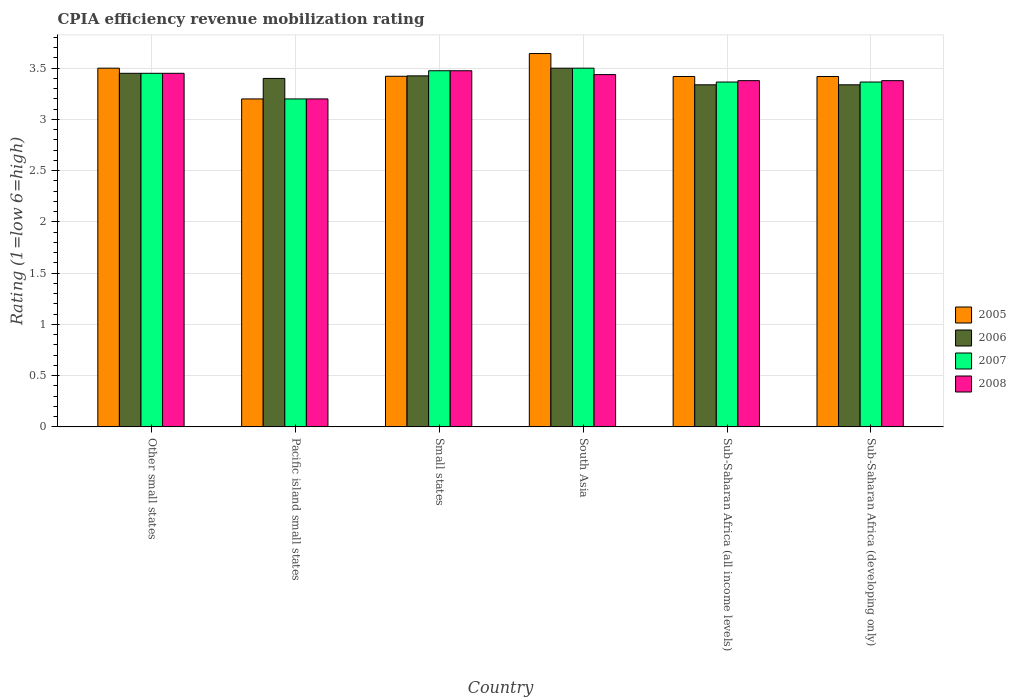Are the number of bars per tick equal to the number of legend labels?
Your answer should be very brief. Yes. Are the number of bars on each tick of the X-axis equal?
Keep it short and to the point. Yes. How many bars are there on the 4th tick from the right?
Offer a very short reply. 4. What is the label of the 3rd group of bars from the left?
Offer a very short reply. Small states. In how many cases, is the number of bars for a given country not equal to the number of legend labels?
Make the answer very short. 0. What is the CPIA rating in 2008 in Small states?
Keep it short and to the point. 3.48. In which country was the CPIA rating in 2007 maximum?
Your answer should be very brief. South Asia. In which country was the CPIA rating in 2007 minimum?
Make the answer very short. Pacific island small states. What is the total CPIA rating in 2007 in the graph?
Your response must be concise. 20.35. What is the difference between the CPIA rating in 2005 in South Asia and the CPIA rating in 2007 in Sub-Saharan Africa (all income levels)?
Provide a succinct answer. 0.28. What is the average CPIA rating in 2006 per country?
Keep it short and to the point. 3.41. What is the difference between the CPIA rating of/in 2007 and CPIA rating of/in 2006 in Sub-Saharan Africa (developing only)?
Offer a terse response. 0.03. What is the ratio of the CPIA rating in 2008 in Pacific island small states to that in Sub-Saharan Africa (developing only)?
Offer a very short reply. 0.95. Is the difference between the CPIA rating in 2007 in Pacific island small states and Sub-Saharan Africa (all income levels) greater than the difference between the CPIA rating in 2006 in Pacific island small states and Sub-Saharan Africa (all income levels)?
Your answer should be very brief. No. What is the difference between the highest and the second highest CPIA rating in 2008?
Provide a short and direct response. 0.01. What is the difference between the highest and the lowest CPIA rating in 2007?
Offer a very short reply. 0.3. Is the sum of the CPIA rating in 2008 in Other small states and Pacific island small states greater than the maximum CPIA rating in 2006 across all countries?
Your answer should be compact. Yes. Is it the case that in every country, the sum of the CPIA rating in 2006 and CPIA rating in 2008 is greater than the sum of CPIA rating in 2005 and CPIA rating in 2007?
Your answer should be compact. No. What does the 4th bar from the right in Pacific island small states represents?
Provide a succinct answer. 2005. Is it the case that in every country, the sum of the CPIA rating in 2007 and CPIA rating in 2006 is greater than the CPIA rating in 2005?
Your answer should be very brief. Yes. How many bars are there?
Your answer should be compact. 24. Are all the bars in the graph horizontal?
Make the answer very short. No. How many countries are there in the graph?
Give a very brief answer. 6. What is the difference between two consecutive major ticks on the Y-axis?
Offer a very short reply. 0.5. Are the values on the major ticks of Y-axis written in scientific E-notation?
Your response must be concise. No. Does the graph contain any zero values?
Ensure brevity in your answer.  No. Does the graph contain grids?
Give a very brief answer. Yes. Where does the legend appear in the graph?
Offer a terse response. Center right. What is the title of the graph?
Your answer should be compact. CPIA efficiency revenue mobilization rating. What is the Rating (1=low 6=high) of 2005 in Other small states?
Keep it short and to the point. 3.5. What is the Rating (1=low 6=high) of 2006 in Other small states?
Ensure brevity in your answer.  3.45. What is the Rating (1=low 6=high) in 2007 in Other small states?
Provide a succinct answer. 3.45. What is the Rating (1=low 6=high) of 2008 in Other small states?
Your answer should be compact. 3.45. What is the Rating (1=low 6=high) of 2005 in Small states?
Provide a short and direct response. 3.42. What is the Rating (1=low 6=high) of 2006 in Small states?
Offer a terse response. 3.42. What is the Rating (1=low 6=high) of 2007 in Small states?
Keep it short and to the point. 3.48. What is the Rating (1=low 6=high) of 2008 in Small states?
Keep it short and to the point. 3.48. What is the Rating (1=low 6=high) in 2005 in South Asia?
Give a very brief answer. 3.64. What is the Rating (1=low 6=high) in 2006 in South Asia?
Ensure brevity in your answer.  3.5. What is the Rating (1=low 6=high) of 2007 in South Asia?
Offer a terse response. 3.5. What is the Rating (1=low 6=high) of 2008 in South Asia?
Ensure brevity in your answer.  3.44. What is the Rating (1=low 6=high) of 2005 in Sub-Saharan Africa (all income levels)?
Provide a succinct answer. 3.42. What is the Rating (1=low 6=high) in 2006 in Sub-Saharan Africa (all income levels)?
Ensure brevity in your answer.  3.34. What is the Rating (1=low 6=high) of 2007 in Sub-Saharan Africa (all income levels)?
Keep it short and to the point. 3.36. What is the Rating (1=low 6=high) in 2008 in Sub-Saharan Africa (all income levels)?
Ensure brevity in your answer.  3.38. What is the Rating (1=low 6=high) in 2005 in Sub-Saharan Africa (developing only)?
Provide a succinct answer. 3.42. What is the Rating (1=low 6=high) in 2006 in Sub-Saharan Africa (developing only)?
Make the answer very short. 3.34. What is the Rating (1=low 6=high) of 2007 in Sub-Saharan Africa (developing only)?
Give a very brief answer. 3.36. What is the Rating (1=low 6=high) in 2008 in Sub-Saharan Africa (developing only)?
Provide a short and direct response. 3.38. Across all countries, what is the maximum Rating (1=low 6=high) in 2005?
Keep it short and to the point. 3.64. Across all countries, what is the maximum Rating (1=low 6=high) in 2008?
Keep it short and to the point. 3.48. Across all countries, what is the minimum Rating (1=low 6=high) of 2006?
Offer a terse response. 3.34. Across all countries, what is the minimum Rating (1=low 6=high) of 2007?
Ensure brevity in your answer.  3.2. Across all countries, what is the minimum Rating (1=low 6=high) of 2008?
Your answer should be compact. 3.2. What is the total Rating (1=low 6=high) in 2005 in the graph?
Ensure brevity in your answer.  20.6. What is the total Rating (1=low 6=high) of 2006 in the graph?
Your response must be concise. 20.45. What is the total Rating (1=low 6=high) of 2007 in the graph?
Keep it short and to the point. 20.35. What is the total Rating (1=low 6=high) of 2008 in the graph?
Your answer should be compact. 20.32. What is the difference between the Rating (1=low 6=high) of 2006 in Other small states and that in Pacific island small states?
Offer a terse response. 0.05. What is the difference between the Rating (1=low 6=high) of 2005 in Other small states and that in Small states?
Give a very brief answer. 0.08. What is the difference between the Rating (1=low 6=high) of 2006 in Other small states and that in Small states?
Keep it short and to the point. 0.03. What is the difference between the Rating (1=low 6=high) in 2007 in Other small states and that in Small states?
Your response must be concise. -0.03. What is the difference between the Rating (1=low 6=high) in 2008 in Other small states and that in Small states?
Provide a short and direct response. -0.03. What is the difference between the Rating (1=low 6=high) in 2005 in Other small states and that in South Asia?
Ensure brevity in your answer.  -0.14. What is the difference between the Rating (1=low 6=high) in 2007 in Other small states and that in South Asia?
Provide a short and direct response. -0.05. What is the difference between the Rating (1=low 6=high) in 2008 in Other small states and that in South Asia?
Make the answer very short. 0.01. What is the difference between the Rating (1=low 6=high) of 2005 in Other small states and that in Sub-Saharan Africa (all income levels)?
Your response must be concise. 0.08. What is the difference between the Rating (1=low 6=high) of 2006 in Other small states and that in Sub-Saharan Africa (all income levels)?
Ensure brevity in your answer.  0.11. What is the difference between the Rating (1=low 6=high) in 2007 in Other small states and that in Sub-Saharan Africa (all income levels)?
Your answer should be compact. 0.09. What is the difference between the Rating (1=low 6=high) of 2008 in Other small states and that in Sub-Saharan Africa (all income levels)?
Offer a terse response. 0.07. What is the difference between the Rating (1=low 6=high) in 2005 in Other small states and that in Sub-Saharan Africa (developing only)?
Your answer should be very brief. 0.08. What is the difference between the Rating (1=low 6=high) of 2006 in Other small states and that in Sub-Saharan Africa (developing only)?
Your response must be concise. 0.11. What is the difference between the Rating (1=low 6=high) of 2007 in Other small states and that in Sub-Saharan Africa (developing only)?
Make the answer very short. 0.09. What is the difference between the Rating (1=low 6=high) in 2008 in Other small states and that in Sub-Saharan Africa (developing only)?
Ensure brevity in your answer.  0.07. What is the difference between the Rating (1=low 6=high) of 2005 in Pacific island small states and that in Small states?
Your answer should be compact. -0.22. What is the difference between the Rating (1=low 6=high) of 2006 in Pacific island small states and that in Small states?
Your response must be concise. -0.03. What is the difference between the Rating (1=low 6=high) of 2007 in Pacific island small states and that in Small states?
Your answer should be compact. -0.28. What is the difference between the Rating (1=low 6=high) of 2008 in Pacific island small states and that in Small states?
Make the answer very short. -0.28. What is the difference between the Rating (1=low 6=high) in 2005 in Pacific island small states and that in South Asia?
Offer a very short reply. -0.44. What is the difference between the Rating (1=low 6=high) of 2008 in Pacific island small states and that in South Asia?
Your answer should be very brief. -0.24. What is the difference between the Rating (1=low 6=high) in 2005 in Pacific island small states and that in Sub-Saharan Africa (all income levels)?
Give a very brief answer. -0.22. What is the difference between the Rating (1=low 6=high) in 2006 in Pacific island small states and that in Sub-Saharan Africa (all income levels)?
Make the answer very short. 0.06. What is the difference between the Rating (1=low 6=high) in 2007 in Pacific island small states and that in Sub-Saharan Africa (all income levels)?
Provide a succinct answer. -0.16. What is the difference between the Rating (1=low 6=high) of 2008 in Pacific island small states and that in Sub-Saharan Africa (all income levels)?
Your answer should be compact. -0.18. What is the difference between the Rating (1=low 6=high) of 2005 in Pacific island small states and that in Sub-Saharan Africa (developing only)?
Provide a succinct answer. -0.22. What is the difference between the Rating (1=low 6=high) of 2006 in Pacific island small states and that in Sub-Saharan Africa (developing only)?
Ensure brevity in your answer.  0.06. What is the difference between the Rating (1=low 6=high) in 2007 in Pacific island small states and that in Sub-Saharan Africa (developing only)?
Provide a succinct answer. -0.16. What is the difference between the Rating (1=low 6=high) in 2008 in Pacific island small states and that in Sub-Saharan Africa (developing only)?
Keep it short and to the point. -0.18. What is the difference between the Rating (1=low 6=high) in 2005 in Small states and that in South Asia?
Keep it short and to the point. -0.22. What is the difference between the Rating (1=low 6=high) in 2006 in Small states and that in South Asia?
Your response must be concise. -0.07. What is the difference between the Rating (1=low 6=high) in 2007 in Small states and that in South Asia?
Provide a succinct answer. -0.03. What is the difference between the Rating (1=low 6=high) in 2008 in Small states and that in South Asia?
Your answer should be very brief. 0.04. What is the difference between the Rating (1=low 6=high) of 2005 in Small states and that in Sub-Saharan Africa (all income levels)?
Your answer should be compact. 0. What is the difference between the Rating (1=low 6=high) of 2006 in Small states and that in Sub-Saharan Africa (all income levels)?
Make the answer very short. 0.09. What is the difference between the Rating (1=low 6=high) of 2007 in Small states and that in Sub-Saharan Africa (all income levels)?
Your answer should be compact. 0.11. What is the difference between the Rating (1=low 6=high) in 2008 in Small states and that in Sub-Saharan Africa (all income levels)?
Ensure brevity in your answer.  0.1. What is the difference between the Rating (1=low 6=high) of 2005 in Small states and that in Sub-Saharan Africa (developing only)?
Ensure brevity in your answer.  0. What is the difference between the Rating (1=low 6=high) of 2006 in Small states and that in Sub-Saharan Africa (developing only)?
Your response must be concise. 0.09. What is the difference between the Rating (1=low 6=high) of 2007 in Small states and that in Sub-Saharan Africa (developing only)?
Offer a very short reply. 0.11. What is the difference between the Rating (1=low 6=high) of 2008 in Small states and that in Sub-Saharan Africa (developing only)?
Your response must be concise. 0.1. What is the difference between the Rating (1=low 6=high) of 2005 in South Asia and that in Sub-Saharan Africa (all income levels)?
Ensure brevity in your answer.  0.22. What is the difference between the Rating (1=low 6=high) of 2006 in South Asia and that in Sub-Saharan Africa (all income levels)?
Ensure brevity in your answer.  0.16. What is the difference between the Rating (1=low 6=high) of 2007 in South Asia and that in Sub-Saharan Africa (all income levels)?
Your answer should be very brief. 0.14. What is the difference between the Rating (1=low 6=high) in 2008 in South Asia and that in Sub-Saharan Africa (all income levels)?
Give a very brief answer. 0.06. What is the difference between the Rating (1=low 6=high) in 2005 in South Asia and that in Sub-Saharan Africa (developing only)?
Ensure brevity in your answer.  0.22. What is the difference between the Rating (1=low 6=high) in 2006 in South Asia and that in Sub-Saharan Africa (developing only)?
Give a very brief answer. 0.16. What is the difference between the Rating (1=low 6=high) of 2007 in South Asia and that in Sub-Saharan Africa (developing only)?
Your answer should be very brief. 0.14. What is the difference between the Rating (1=low 6=high) in 2008 in South Asia and that in Sub-Saharan Africa (developing only)?
Your response must be concise. 0.06. What is the difference between the Rating (1=low 6=high) in 2008 in Sub-Saharan Africa (all income levels) and that in Sub-Saharan Africa (developing only)?
Ensure brevity in your answer.  0. What is the difference between the Rating (1=low 6=high) in 2005 in Other small states and the Rating (1=low 6=high) in 2006 in Small states?
Give a very brief answer. 0.07. What is the difference between the Rating (1=low 6=high) in 2005 in Other small states and the Rating (1=low 6=high) in 2007 in Small states?
Ensure brevity in your answer.  0.03. What is the difference between the Rating (1=low 6=high) of 2005 in Other small states and the Rating (1=low 6=high) of 2008 in Small states?
Your answer should be compact. 0.03. What is the difference between the Rating (1=low 6=high) of 2006 in Other small states and the Rating (1=low 6=high) of 2007 in Small states?
Your response must be concise. -0.03. What is the difference between the Rating (1=low 6=high) in 2006 in Other small states and the Rating (1=low 6=high) in 2008 in Small states?
Make the answer very short. -0.03. What is the difference between the Rating (1=low 6=high) in 2007 in Other small states and the Rating (1=low 6=high) in 2008 in Small states?
Keep it short and to the point. -0.03. What is the difference between the Rating (1=low 6=high) in 2005 in Other small states and the Rating (1=low 6=high) in 2007 in South Asia?
Offer a very short reply. 0. What is the difference between the Rating (1=low 6=high) of 2005 in Other small states and the Rating (1=low 6=high) of 2008 in South Asia?
Provide a succinct answer. 0.06. What is the difference between the Rating (1=low 6=high) of 2006 in Other small states and the Rating (1=low 6=high) of 2008 in South Asia?
Ensure brevity in your answer.  0.01. What is the difference between the Rating (1=low 6=high) in 2007 in Other small states and the Rating (1=low 6=high) in 2008 in South Asia?
Offer a terse response. 0.01. What is the difference between the Rating (1=low 6=high) of 2005 in Other small states and the Rating (1=low 6=high) of 2006 in Sub-Saharan Africa (all income levels)?
Make the answer very short. 0.16. What is the difference between the Rating (1=low 6=high) in 2005 in Other small states and the Rating (1=low 6=high) in 2007 in Sub-Saharan Africa (all income levels)?
Offer a very short reply. 0.14. What is the difference between the Rating (1=low 6=high) of 2005 in Other small states and the Rating (1=low 6=high) of 2008 in Sub-Saharan Africa (all income levels)?
Offer a terse response. 0.12. What is the difference between the Rating (1=low 6=high) of 2006 in Other small states and the Rating (1=low 6=high) of 2007 in Sub-Saharan Africa (all income levels)?
Ensure brevity in your answer.  0.09. What is the difference between the Rating (1=low 6=high) of 2006 in Other small states and the Rating (1=low 6=high) of 2008 in Sub-Saharan Africa (all income levels)?
Your answer should be compact. 0.07. What is the difference between the Rating (1=low 6=high) of 2007 in Other small states and the Rating (1=low 6=high) of 2008 in Sub-Saharan Africa (all income levels)?
Ensure brevity in your answer.  0.07. What is the difference between the Rating (1=low 6=high) in 2005 in Other small states and the Rating (1=low 6=high) in 2006 in Sub-Saharan Africa (developing only)?
Provide a succinct answer. 0.16. What is the difference between the Rating (1=low 6=high) of 2005 in Other small states and the Rating (1=low 6=high) of 2007 in Sub-Saharan Africa (developing only)?
Make the answer very short. 0.14. What is the difference between the Rating (1=low 6=high) of 2005 in Other small states and the Rating (1=low 6=high) of 2008 in Sub-Saharan Africa (developing only)?
Make the answer very short. 0.12. What is the difference between the Rating (1=low 6=high) of 2006 in Other small states and the Rating (1=low 6=high) of 2007 in Sub-Saharan Africa (developing only)?
Provide a succinct answer. 0.09. What is the difference between the Rating (1=low 6=high) of 2006 in Other small states and the Rating (1=low 6=high) of 2008 in Sub-Saharan Africa (developing only)?
Your answer should be very brief. 0.07. What is the difference between the Rating (1=low 6=high) in 2007 in Other small states and the Rating (1=low 6=high) in 2008 in Sub-Saharan Africa (developing only)?
Provide a succinct answer. 0.07. What is the difference between the Rating (1=low 6=high) of 2005 in Pacific island small states and the Rating (1=low 6=high) of 2006 in Small states?
Ensure brevity in your answer.  -0.23. What is the difference between the Rating (1=low 6=high) in 2005 in Pacific island small states and the Rating (1=low 6=high) in 2007 in Small states?
Offer a very short reply. -0.28. What is the difference between the Rating (1=low 6=high) in 2005 in Pacific island small states and the Rating (1=low 6=high) in 2008 in Small states?
Your answer should be very brief. -0.28. What is the difference between the Rating (1=low 6=high) in 2006 in Pacific island small states and the Rating (1=low 6=high) in 2007 in Small states?
Keep it short and to the point. -0.07. What is the difference between the Rating (1=low 6=high) in 2006 in Pacific island small states and the Rating (1=low 6=high) in 2008 in Small states?
Your answer should be very brief. -0.07. What is the difference between the Rating (1=low 6=high) in 2007 in Pacific island small states and the Rating (1=low 6=high) in 2008 in Small states?
Give a very brief answer. -0.28. What is the difference between the Rating (1=low 6=high) in 2005 in Pacific island small states and the Rating (1=low 6=high) in 2008 in South Asia?
Provide a succinct answer. -0.24. What is the difference between the Rating (1=low 6=high) of 2006 in Pacific island small states and the Rating (1=low 6=high) of 2007 in South Asia?
Your answer should be compact. -0.1. What is the difference between the Rating (1=low 6=high) of 2006 in Pacific island small states and the Rating (1=low 6=high) of 2008 in South Asia?
Your answer should be very brief. -0.04. What is the difference between the Rating (1=low 6=high) of 2007 in Pacific island small states and the Rating (1=low 6=high) of 2008 in South Asia?
Provide a short and direct response. -0.24. What is the difference between the Rating (1=low 6=high) in 2005 in Pacific island small states and the Rating (1=low 6=high) in 2006 in Sub-Saharan Africa (all income levels)?
Ensure brevity in your answer.  -0.14. What is the difference between the Rating (1=low 6=high) in 2005 in Pacific island small states and the Rating (1=low 6=high) in 2007 in Sub-Saharan Africa (all income levels)?
Offer a terse response. -0.16. What is the difference between the Rating (1=low 6=high) of 2005 in Pacific island small states and the Rating (1=low 6=high) of 2008 in Sub-Saharan Africa (all income levels)?
Your response must be concise. -0.18. What is the difference between the Rating (1=low 6=high) of 2006 in Pacific island small states and the Rating (1=low 6=high) of 2007 in Sub-Saharan Africa (all income levels)?
Give a very brief answer. 0.04. What is the difference between the Rating (1=low 6=high) in 2006 in Pacific island small states and the Rating (1=low 6=high) in 2008 in Sub-Saharan Africa (all income levels)?
Your response must be concise. 0.02. What is the difference between the Rating (1=low 6=high) of 2007 in Pacific island small states and the Rating (1=low 6=high) of 2008 in Sub-Saharan Africa (all income levels)?
Provide a short and direct response. -0.18. What is the difference between the Rating (1=low 6=high) in 2005 in Pacific island small states and the Rating (1=low 6=high) in 2006 in Sub-Saharan Africa (developing only)?
Provide a succinct answer. -0.14. What is the difference between the Rating (1=low 6=high) in 2005 in Pacific island small states and the Rating (1=low 6=high) in 2007 in Sub-Saharan Africa (developing only)?
Provide a succinct answer. -0.16. What is the difference between the Rating (1=low 6=high) in 2005 in Pacific island small states and the Rating (1=low 6=high) in 2008 in Sub-Saharan Africa (developing only)?
Your answer should be compact. -0.18. What is the difference between the Rating (1=low 6=high) of 2006 in Pacific island small states and the Rating (1=low 6=high) of 2007 in Sub-Saharan Africa (developing only)?
Offer a terse response. 0.04. What is the difference between the Rating (1=low 6=high) in 2006 in Pacific island small states and the Rating (1=low 6=high) in 2008 in Sub-Saharan Africa (developing only)?
Keep it short and to the point. 0.02. What is the difference between the Rating (1=low 6=high) in 2007 in Pacific island small states and the Rating (1=low 6=high) in 2008 in Sub-Saharan Africa (developing only)?
Your answer should be very brief. -0.18. What is the difference between the Rating (1=low 6=high) of 2005 in Small states and the Rating (1=low 6=high) of 2006 in South Asia?
Provide a succinct answer. -0.08. What is the difference between the Rating (1=low 6=high) of 2005 in Small states and the Rating (1=low 6=high) of 2007 in South Asia?
Your response must be concise. -0.08. What is the difference between the Rating (1=low 6=high) of 2005 in Small states and the Rating (1=low 6=high) of 2008 in South Asia?
Ensure brevity in your answer.  -0.02. What is the difference between the Rating (1=low 6=high) of 2006 in Small states and the Rating (1=low 6=high) of 2007 in South Asia?
Make the answer very short. -0.07. What is the difference between the Rating (1=low 6=high) of 2006 in Small states and the Rating (1=low 6=high) of 2008 in South Asia?
Keep it short and to the point. -0.01. What is the difference between the Rating (1=low 6=high) in 2007 in Small states and the Rating (1=low 6=high) in 2008 in South Asia?
Keep it short and to the point. 0.04. What is the difference between the Rating (1=low 6=high) of 2005 in Small states and the Rating (1=low 6=high) of 2006 in Sub-Saharan Africa (all income levels)?
Ensure brevity in your answer.  0.08. What is the difference between the Rating (1=low 6=high) in 2005 in Small states and the Rating (1=low 6=high) in 2007 in Sub-Saharan Africa (all income levels)?
Offer a very short reply. 0.06. What is the difference between the Rating (1=low 6=high) in 2005 in Small states and the Rating (1=low 6=high) in 2008 in Sub-Saharan Africa (all income levels)?
Your answer should be compact. 0.04. What is the difference between the Rating (1=low 6=high) in 2006 in Small states and the Rating (1=low 6=high) in 2007 in Sub-Saharan Africa (all income levels)?
Make the answer very short. 0.06. What is the difference between the Rating (1=low 6=high) in 2006 in Small states and the Rating (1=low 6=high) in 2008 in Sub-Saharan Africa (all income levels)?
Your answer should be very brief. 0.05. What is the difference between the Rating (1=low 6=high) in 2007 in Small states and the Rating (1=low 6=high) in 2008 in Sub-Saharan Africa (all income levels)?
Offer a terse response. 0.1. What is the difference between the Rating (1=low 6=high) in 2005 in Small states and the Rating (1=low 6=high) in 2006 in Sub-Saharan Africa (developing only)?
Ensure brevity in your answer.  0.08. What is the difference between the Rating (1=low 6=high) in 2005 in Small states and the Rating (1=low 6=high) in 2007 in Sub-Saharan Africa (developing only)?
Your response must be concise. 0.06. What is the difference between the Rating (1=low 6=high) of 2005 in Small states and the Rating (1=low 6=high) of 2008 in Sub-Saharan Africa (developing only)?
Offer a very short reply. 0.04. What is the difference between the Rating (1=low 6=high) in 2006 in Small states and the Rating (1=low 6=high) in 2007 in Sub-Saharan Africa (developing only)?
Your answer should be very brief. 0.06. What is the difference between the Rating (1=low 6=high) in 2006 in Small states and the Rating (1=low 6=high) in 2008 in Sub-Saharan Africa (developing only)?
Offer a very short reply. 0.05. What is the difference between the Rating (1=low 6=high) of 2007 in Small states and the Rating (1=low 6=high) of 2008 in Sub-Saharan Africa (developing only)?
Offer a terse response. 0.1. What is the difference between the Rating (1=low 6=high) in 2005 in South Asia and the Rating (1=low 6=high) in 2006 in Sub-Saharan Africa (all income levels)?
Offer a very short reply. 0.3. What is the difference between the Rating (1=low 6=high) of 2005 in South Asia and the Rating (1=low 6=high) of 2007 in Sub-Saharan Africa (all income levels)?
Offer a very short reply. 0.28. What is the difference between the Rating (1=low 6=high) in 2005 in South Asia and the Rating (1=low 6=high) in 2008 in Sub-Saharan Africa (all income levels)?
Give a very brief answer. 0.26. What is the difference between the Rating (1=low 6=high) of 2006 in South Asia and the Rating (1=low 6=high) of 2007 in Sub-Saharan Africa (all income levels)?
Ensure brevity in your answer.  0.14. What is the difference between the Rating (1=low 6=high) in 2006 in South Asia and the Rating (1=low 6=high) in 2008 in Sub-Saharan Africa (all income levels)?
Your response must be concise. 0.12. What is the difference between the Rating (1=low 6=high) in 2007 in South Asia and the Rating (1=low 6=high) in 2008 in Sub-Saharan Africa (all income levels)?
Ensure brevity in your answer.  0.12. What is the difference between the Rating (1=low 6=high) of 2005 in South Asia and the Rating (1=low 6=high) of 2006 in Sub-Saharan Africa (developing only)?
Keep it short and to the point. 0.3. What is the difference between the Rating (1=low 6=high) in 2005 in South Asia and the Rating (1=low 6=high) in 2007 in Sub-Saharan Africa (developing only)?
Your answer should be very brief. 0.28. What is the difference between the Rating (1=low 6=high) of 2005 in South Asia and the Rating (1=low 6=high) of 2008 in Sub-Saharan Africa (developing only)?
Provide a succinct answer. 0.26. What is the difference between the Rating (1=low 6=high) of 2006 in South Asia and the Rating (1=low 6=high) of 2007 in Sub-Saharan Africa (developing only)?
Ensure brevity in your answer.  0.14. What is the difference between the Rating (1=low 6=high) in 2006 in South Asia and the Rating (1=low 6=high) in 2008 in Sub-Saharan Africa (developing only)?
Your answer should be very brief. 0.12. What is the difference between the Rating (1=low 6=high) of 2007 in South Asia and the Rating (1=low 6=high) of 2008 in Sub-Saharan Africa (developing only)?
Provide a succinct answer. 0.12. What is the difference between the Rating (1=low 6=high) in 2005 in Sub-Saharan Africa (all income levels) and the Rating (1=low 6=high) in 2006 in Sub-Saharan Africa (developing only)?
Provide a succinct answer. 0.08. What is the difference between the Rating (1=low 6=high) of 2005 in Sub-Saharan Africa (all income levels) and the Rating (1=low 6=high) of 2007 in Sub-Saharan Africa (developing only)?
Provide a succinct answer. 0.05. What is the difference between the Rating (1=low 6=high) of 2005 in Sub-Saharan Africa (all income levels) and the Rating (1=low 6=high) of 2008 in Sub-Saharan Africa (developing only)?
Your answer should be very brief. 0.04. What is the difference between the Rating (1=low 6=high) in 2006 in Sub-Saharan Africa (all income levels) and the Rating (1=low 6=high) in 2007 in Sub-Saharan Africa (developing only)?
Provide a succinct answer. -0.03. What is the difference between the Rating (1=low 6=high) of 2006 in Sub-Saharan Africa (all income levels) and the Rating (1=low 6=high) of 2008 in Sub-Saharan Africa (developing only)?
Provide a succinct answer. -0.04. What is the difference between the Rating (1=low 6=high) in 2007 in Sub-Saharan Africa (all income levels) and the Rating (1=low 6=high) in 2008 in Sub-Saharan Africa (developing only)?
Your response must be concise. -0.01. What is the average Rating (1=low 6=high) of 2005 per country?
Offer a terse response. 3.43. What is the average Rating (1=low 6=high) in 2006 per country?
Your response must be concise. 3.41. What is the average Rating (1=low 6=high) in 2007 per country?
Give a very brief answer. 3.39. What is the average Rating (1=low 6=high) in 2008 per country?
Your answer should be compact. 3.39. What is the difference between the Rating (1=low 6=high) of 2005 and Rating (1=low 6=high) of 2007 in Other small states?
Keep it short and to the point. 0.05. What is the difference between the Rating (1=low 6=high) in 2005 and Rating (1=low 6=high) in 2008 in Other small states?
Provide a short and direct response. 0.05. What is the difference between the Rating (1=low 6=high) in 2006 and Rating (1=low 6=high) in 2007 in Other small states?
Your answer should be very brief. 0. What is the difference between the Rating (1=low 6=high) of 2006 and Rating (1=low 6=high) of 2008 in Other small states?
Provide a short and direct response. 0. What is the difference between the Rating (1=low 6=high) in 2005 and Rating (1=low 6=high) in 2008 in Pacific island small states?
Provide a short and direct response. 0. What is the difference between the Rating (1=low 6=high) in 2006 and Rating (1=low 6=high) in 2007 in Pacific island small states?
Your answer should be compact. 0.2. What is the difference between the Rating (1=low 6=high) of 2006 and Rating (1=low 6=high) of 2008 in Pacific island small states?
Offer a very short reply. 0.2. What is the difference between the Rating (1=low 6=high) in 2007 and Rating (1=low 6=high) in 2008 in Pacific island small states?
Provide a short and direct response. 0. What is the difference between the Rating (1=low 6=high) of 2005 and Rating (1=low 6=high) of 2006 in Small states?
Your response must be concise. -0. What is the difference between the Rating (1=low 6=high) of 2005 and Rating (1=low 6=high) of 2007 in Small states?
Keep it short and to the point. -0.05. What is the difference between the Rating (1=low 6=high) in 2005 and Rating (1=low 6=high) in 2008 in Small states?
Offer a very short reply. -0.05. What is the difference between the Rating (1=low 6=high) in 2006 and Rating (1=low 6=high) in 2007 in Small states?
Keep it short and to the point. -0.05. What is the difference between the Rating (1=low 6=high) in 2005 and Rating (1=low 6=high) in 2006 in South Asia?
Your response must be concise. 0.14. What is the difference between the Rating (1=low 6=high) in 2005 and Rating (1=low 6=high) in 2007 in South Asia?
Your answer should be compact. 0.14. What is the difference between the Rating (1=low 6=high) in 2005 and Rating (1=low 6=high) in 2008 in South Asia?
Keep it short and to the point. 0.21. What is the difference between the Rating (1=low 6=high) of 2006 and Rating (1=low 6=high) of 2007 in South Asia?
Ensure brevity in your answer.  0. What is the difference between the Rating (1=low 6=high) in 2006 and Rating (1=low 6=high) in 2008 in South Asia?
Make the answer very short. 0.06. What is the difference between the Rating (1=low 6=high) of 2007 and Rating (1=low 6=high) of 2008 in South Asia?
Offer a terse response. 0.06. What is the difference between the Rating (1=low 6=high) in 2005 and Rating (1=low 6=high) in 2006 in Sub-Saharan Africa (all income levels)?
Keep it short and to the point. 0.08. What is the difference between the Rating (1=low 6=high) in 2005 and Rating (1=low 6=high) in 2007 in Sub-Saharan Africa (all income levels)?
Provide a succinct answer. 0.05. What is the difference between the Rating (1=low 6=high) of 2005 and Rating (1=low 6=high) of 2008 in Sub-Saharan Africa (all income levels)?
Your answer should be very brief. 0.04. What is the difference between the Rating (1=low 6=high) in 2006 and Rating (1=low 6=high) in 2007 in Sub-Saharan Africa (all income levels)?
Your answer should be very brief. -0.03. What is the difference between the Rating (1=low 6=high) in 2006 and Rating (1=low 6=high) in 2008 in Sub-Saharan Africa (all income levels)?
Provide a succinct answer. -0.04. What is the difference between the Rating (1=low 6=high) of 2007 and Rating (1=low 6=high) of 2008 in Sub-Saharan Africa (all income levels)?
Your answer should be compact. -0.01. What is the difference between the Rating (1=low 6=high) of 2005 and Rating (1=low 6=high) of 2006 in Sub-Saharan Africa (developing only)?
Offer a very short reply. 0.08. What is the difference between the Rating (1=low 6=high) of 2005 and Rating (1=low 6=high) of 2007 in Sub-Saharan Africa (developing only)?
Provide a succinct answer. 0.05. What is the difference between the Rating (1=low 6=high) in 2005 and Rating (1=low 6=high) in 2008 in Sub-Saharan Africa (developing only)?
Offer a terse response. 0.04. What is the difference between the Rating (1=low 6=high) in 2006 and Rating (1=low 6=high) in 2007 in Sub-Saharan Africa (developing only)?
Provide a short and direct response. -0.03. What is the difference between the Rating (1=low 6=high) in 2006 and Rating (1=low 6=high) in 2008 in Sub-Saharan Africa (developing only)?
Provide a short and direct response. -0.04. What is the difference between the Rating (1=low 6=high) of 2007 and Rating (1=low 6=high) of 2008 in Sub-Saharan Africa (developing only)?
Your answer should be compact. -0.01. What is the ratio of the Rating (1=low 6=high) of 2005 in Other small states to that in Pacific island small states?
Offer a very short reply. 1.09. What is the ratio of the Rating (1=low 6=high) in 2006 in Other small states to that in Pacific island small states?
Give a very brief answer. 1.01. What is the ratio of the Rating (1=low 6=high) of 2007 in Other small states to that in Pacific island small states?
Provide a short and direct response. 1.08. What is the ratio of the Rating (1=low 6=high) of 2008 in Other small states to that in Pacific island small states?
Provide a short and direct response. 1.08. What is the ratio of the Rating (1=low 6=high) in 2005 in Other small states to that in Small states?
Provide a succinct answer. 1.02. What is the ratio of the Rating (1=low 6=high) of 2006 in Other small states to that in Small states?
Make the answer very short. 1.01. What is the ratio of the Rating (1=low 6=high) of 2007 in Other small states to that in Small states?
Keep it short and to the point. 0.99. What is the ratio of the Rating (1=low 6=high) of 2005 in Other small states to that in South Asia?
Your answer should be compact. 0.96. What is the ratio of the Rating (1=low 6=high) in 2006 in Other small states to that in South Asia?
Provide a succinct answer. 0.99. What is the ratio of the Rating (1=low 6=high) of 2007 in Other small states to that in South Asia?
Your answer should be compact. 0.99. What is the ratio of the Rating (1=low 6=high) in 2005 in Other small states to that in Sub-Saharan Africa (all income levels)?
Provide a succinct answer. 1.02. What is the ratio of the Rating (1=low 6=high) in 2006 in Other small states to that in Sub-Saharan Africa (all income levels)?
Offer a very short reply. 1.03. What is the ratio of the Rating (1=low 6=high) of 2007 in Other small states to that in Sub-Saharan Africa (all income levels)?
Make the answer very short. 1.03. What is the ratio of the Rating (1=low 6=high) of 2008 in Other small states to that in Sub-Saharan Africa (all income levels)?
Keep it short and to the point. 1.02. What is the ratio of the Rating (1=low 6=high) in 2005 in Other small states to that in Sub-Saharan Africa (developing only)?
Provide a succinct answer. 1.02. What is the ratio of the Rating (1=low 6=high) in 2006 in Other small states to that in Sub-Saharan Africa (developing only)?
Keep it short and to the point. 1.03. What is the ratio of the Rating (1=low 6=high) of 2007 in Other small states to that in Sub-Saharan Africa (developing only)?
Offer a terse response. 1.03. What is the ratio of the Rating (1=low 6=high) of 2008 in Other small states to that in Sub-Saharan Africa (developing only)?
Keep it short and to the point. 1.02. What is the ratio of the Rating (1=low 6=high) in 2005 in Pacific island small states to that in Small states?
Your answer should be very brief. 0.94. What is the ratio of the Rating (1=low 6=high) of 2007 in Pacific island small states to that in Small states?
Keep it short and to the point. 0.92. What is the ratio of the Rating (1=low 6=high) of 2008 in Pacific island small states to that in Small states?
Provide a short and direct response. 0.92. What is the ratio of the Rating (1=low 6=high) of 2005 in Pacific island small states to that in South Asia?
Your answer should be compact. 0.88. What is the ratio of the Rating (1=low 6=high) in 2006 in Pacific island small states to that in South Asia?
Offer a terse response. 0.97. What is the ratio of the Rating (1=low 6=high) of 2007 in Pacific island small states to that in South Asia?
Make the answer very short. 0.91. What is the ratio of the Rating (1=low 6=high) of 2008 in Pacific island small states to that in South Asia?
Your answer should be very brief. 0.93. What is the ratio of the Rating (1=low 6=high) of 2005 in Pacific island small states to that in Sub-Saharan Africa (all income levels)?
Offer a terse response. 0.94. What is the ratio of the Rating (1=low 6=high) of 2006 in Pacific island small states to that in Sub-Saharan Africa (all income levels)?
Offer a very short reply. 1.02. What is the ratio of the Rating (1=low 6=high) of 2007 in Pacific island small states to that in Sub-Saharan Africa (all income levels)?
Keep it short and to the point. 0.95. What is the ratio of the Rating (1=low 6=high) in 2008 in Pacific island small states to that in Sub-Saharan Africa (all income levels)?
Your answer should be compact. 0.95. What is the ratio of the Rating (1=low 6=high) of 2005 in Pacific island small states to that in Sub-Saharan Africa (developing only)?
Your answer should be very brief. 0.94. What is the ratio of the Rating (1=low 6=high) of 2006 in Pacific island small states to that in Sub-Saharan Africa (developing only)?
Offer a very short reply. 1.02. What is the ratio of the Rating (1=low 6=high) in 2007 in Pacific island small states to that in Sub-Saharan Africa (developing only)?
Give a very brief answer. 0.95. What is the ratio of the Rating (1=low 6=high) in 2008 in Pacific island small states to that in Sub-Saharan Africa (developing only)?
Provide a succinct answer. 0.95. What is the ratio of the Rating (1=low 6=high) in 2005 in Small states to that in South Asia?
Keep it short and to the point. 0.94. What is the ratio of the Rating (1=low 6=high) of 2006 in Small states to that in South Asia?
Make the answer very short. 0.98. What is the ratio of the Rating (1=low 6=high) in 2007 in Small states to that in South Asia?
Give a very brief answer. 0.99. What is the ratio of the Rating (1=low 6=high) of 2008 in Small states to that in South Asia?
Provide a short and direct response. 1.01. What is the ratio of the Rating (1=low 6=high) in 2005 in Small states to that in Sub-Saharan Africa (all income levels)?
Make the answer very short. 1. What is the ratio of the Rating (1=low 6=high) of 2006 in Small states to that in Sub-Saharan Africa (all income levels)?
Offer a very short reply. 1.03. What is the ratio of the Rating (1=low 6=high) in 2007 in Small states to that in Sub-Saharan Africa (all income levels)?
Keep it short and to the point. 1.03. What is the ratio of the Rating (1=low 6=high) in 2008 in Small states to that in Sub-Saharan Africa (all income levels)?
Offer a terse response. 1.03. What is the ratio of the Rating (1=low 6=high) in 2005 in Small states to that in Sub-Saharan Africa (developing only)?
Your answer should be very brief. 1. What is the ratio of the Rating (1=low 6=high) of 2006 in Small states to that in Sub-Saharan Africa (developing only)?
Provide a succinct answer. 1.03. What is the ratio of the Rating (1=low 6=high) of 2007 in Small states to that in Sub-Saharan Africa (developing only)?
Provide a short and direct response. 1.03. What is the ratio of the Rating (1=low 6=high) in 2008 in Small states to that in Sub-Saharan Africa (developing only)?
Make the answer very short. 1.03. What is the ratio of the Rating (1=low 6=high) of 2005 in South Asia to that in Sub-Saharan Africa (all income levels)?
Offer a very short reply. 1.07. What is the ratio of the Rating (1=low 6=high) of 2006 in South Asia to that in Sub-Saharan Africa (all income levels)?
Your answer should be very brief. 1.05. What is the ratio of the Rating (1=low 6=high) in 2007 in South Asia to that in Sub-Saharan Africa (all income levels)?
Give a very brief answer. 1.04. What is the ratio of the Rating (1=low 6=high) of 2008 in South Asia to that in Sub-Saharan Africa (all income levels)?
Keep it short and to the point. 1.02. What is the ratio of the Rating (1=low 6=high) of 2005 in South Asia to that in Sub-Saharan Africa (developing only)?
Your response must be concise. 1.07. What is the ratio of the Rating (1=low 6=high) of 2006 in South Asia to that in Sub-Saharan Africa (developing only)?
Your answer should be very brief. 1.05. What is the ratio of the Rating (1=low 6=high) of 2007 in South Asia to that in Sub-Saharan Africa (developing only)?
Ensure brevity in your answer.  1.04. What is the ratio of the Rating (1=low 6=high) of 2008 in South Asia to that in Sub-Saharan Africa (developing only)?
Your answer should be very brief. 1.02. What is the ratio of the Rating (1=low 6=high) in 2005 in Sub-Saharan Africa (all income levels) to that in Sub-Saharan Africa (developing only)?
Provide a succinct answer. 1. What is the ratio of the Rating (1=low 6=high) of 2007 in Sub-Saharan Africa (all income levels) to that in Sub-Saharan Africa (developing only)?
Make the answer very short. 1. What is the difference between the highest and the second highest Rating (1=low 6=high) in 2005?
Provide a succinct answer. 0.14. What is the difference between the highest and the second highest Rating (1=low 6=high) in 2006?
Ensure brevity in your answer.  0.05. What is the difference between the highest and the second highest Rating (1=low 6=high) of 2007?
Provide a short and direct response. 0.03. What is the difference between the highest and the second highest Rating (1=low 6=high) of 2008?
Keep it short and to the point. 0.03. What is the difference between the highest and the lowest Rating (1=low 6=high) in 2005?
Keep it short and to the point. 0.44. What is the difference between the highest and the lowest Rating (1=low 6=high) in 2006?
Offer a terse response. 0.16. What is the difference between the highest and the lowest Rating (1=low 6=high) in 2007?
Your response must be concise. 0.3. What is the difference between the highest and the lowest Rating (1=low 6=high) of 2008?
Ensure brevity in your answer.  0.28. 